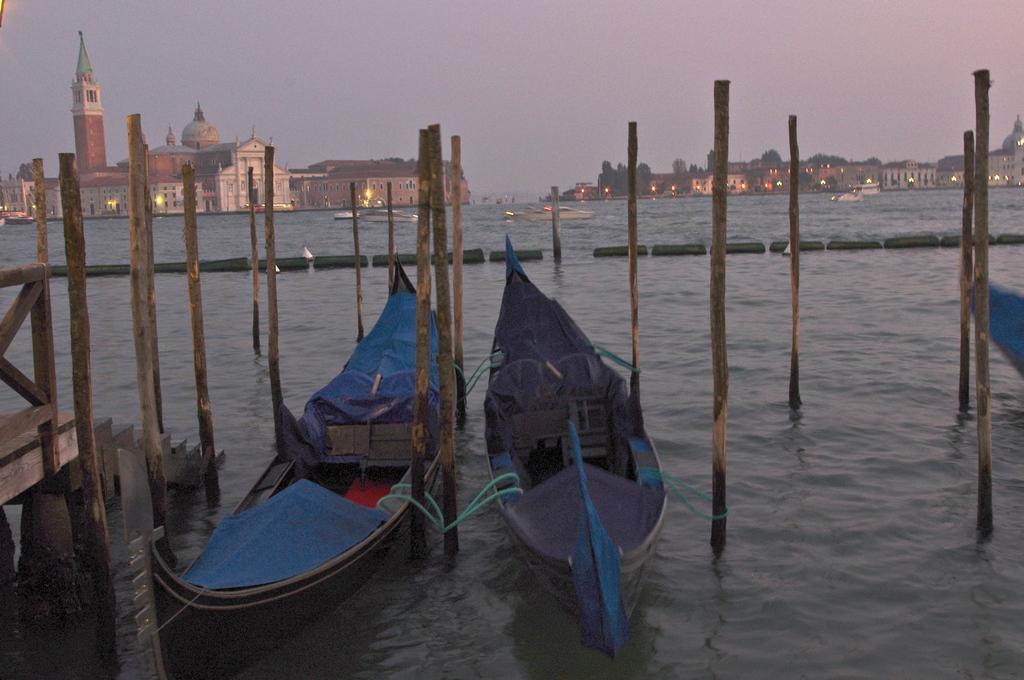Describe this image in one or two sentences. In this image we can see boats, bamboo poles. At the bottom of the image there is water. In the background of the image there are buildings and sky. 